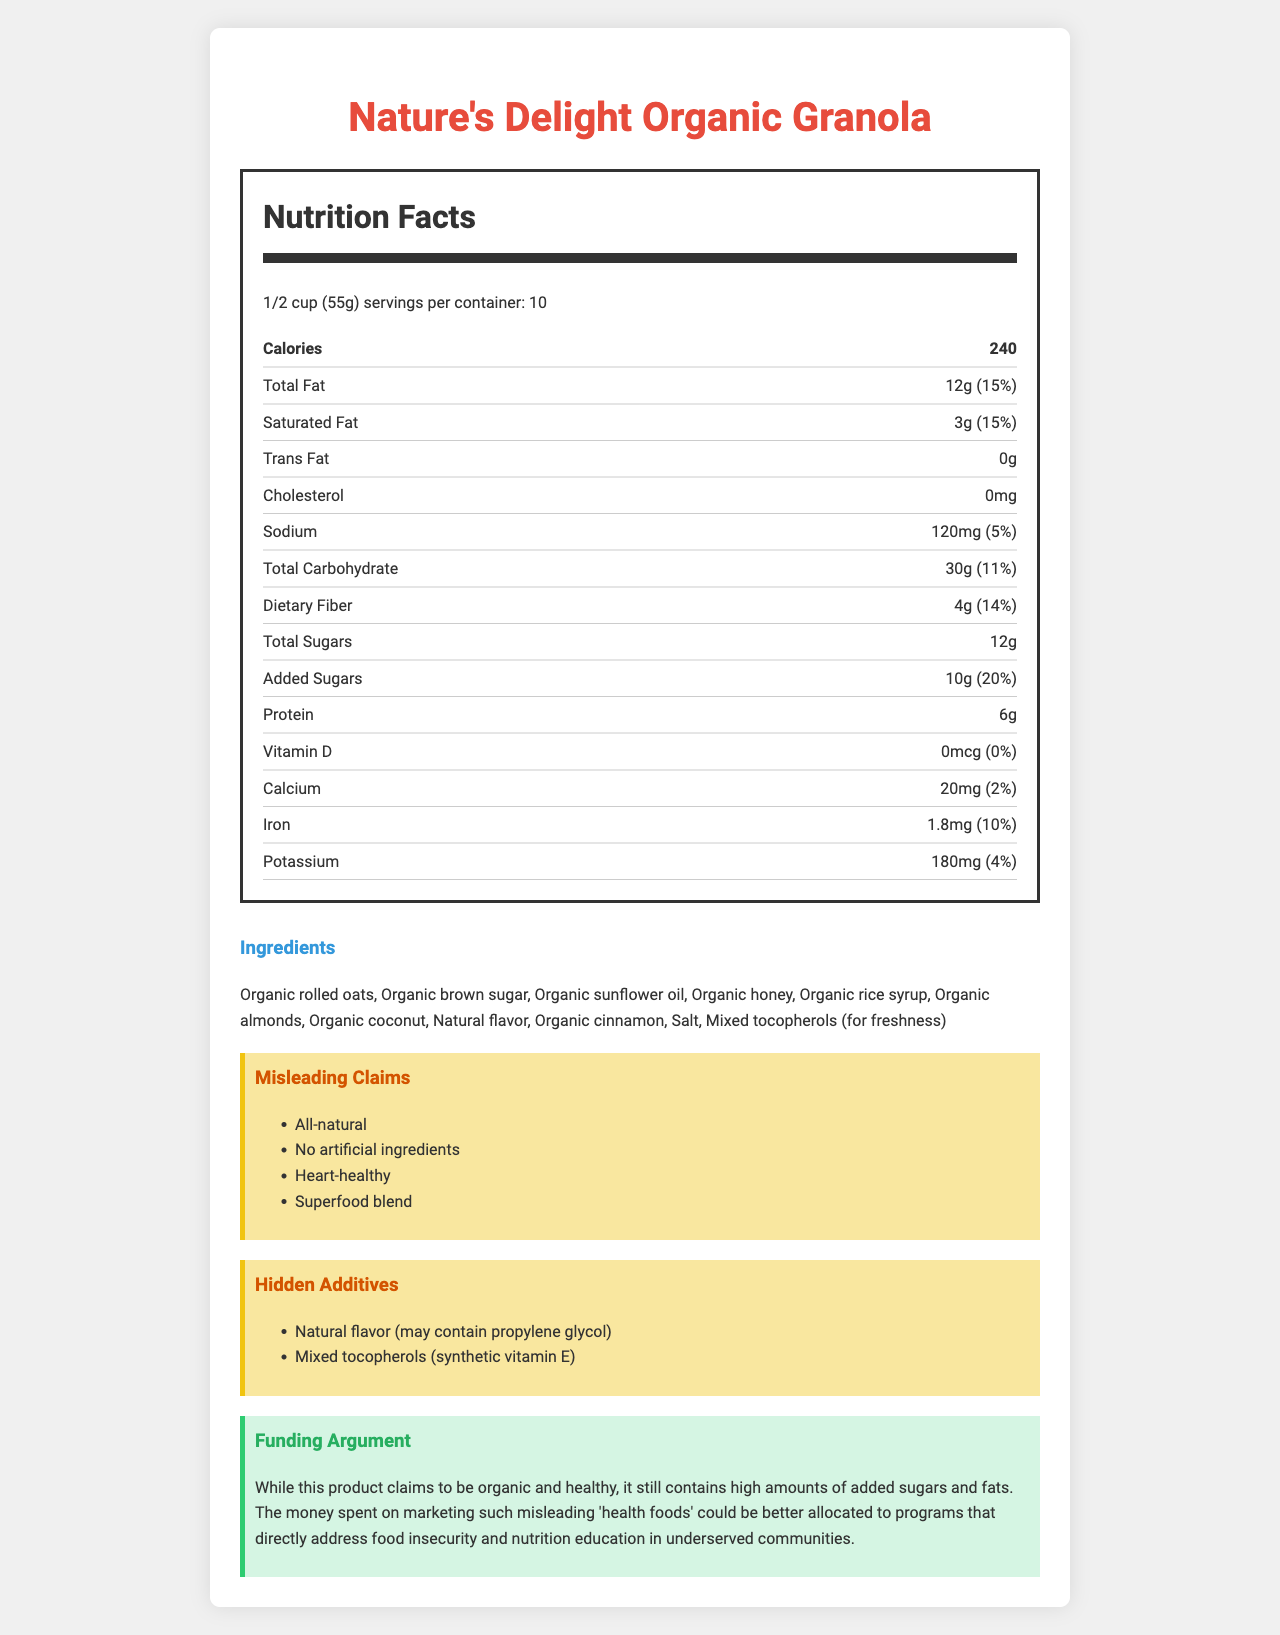What is the serving size for Nature's Delight Organic Granola? The serving size is clearly stated at the top of the Nutrition Facts label.
Answer: 1/2 cup (55g) How many calories are in one serving? The Nutrition Facts label lists the number of calories per serving as 240.
Answer: 240 How much is the total fat content per serving? The Nutrition Facts label specifies that the total fat content per serving is 12g.
Answer: 12g What is the amount of dietary fiber per serving? The amount of dietary fiber per serving is listed as 4g in the Nutrition Facts.
Answer: 4g What percentage of the daily value does the added sugars constitute? The label shows that added sugars are 10g per serving, which is 20% of the daily value.
Answer: 20% Which of the following is a hidden additive in the granola? A. Organic honey B. Natural flavor C. Organic rolled oats D. Organic brown sugar Natural flavor is identified as one of the hidden additives that may contain propylene glycol.
Answer: B Identify one misleading health claim made by the product. The document indicates that "Heart-healthy" is one of the misleading claims made by the product.
Answer: Heart-healthy How many servings are there per container? The Nutrition Facts label indicates that there are 10 servings per container.
Answer: 10 Is the granola cholesterol-free? The Nutrition Facts label lists cholesterol as 0mg, indicating that it is cholesterol-free.
Answer: Yes Why might someone argue that the funding for marketing this product should be reallocated? The argument section states that the product contains high amounts of added sugars and fats, suggesting funds could be better spent on addressing food insecurity and nutrition education.
Answer: High amounts of added sugars and fats Does the product contain any synthetic additives? The document lists mixed tocopherols (synthetic vitamin E) as a hidden additive.
Answer: Yes Estimate the total amount of carbohydrates in the entire container. With 30g of total carbohydrates per serving and 10 servings per container, the total amount is 30g x 10 = 300g.
Answer: 300g Summarize the main points of the document. The document provides a detailed breakdown of the nutritional content, ingredients, and misleading marketing claims of the granola, emphasizing the need for funding to be used on other social programs instead.
Answer: The document analyzes the Nutrition Facts label for Nature's Delight Organic Granola, pointing out high levels of added sugars and fats despite its health claims. It highlights misleading claims and hidden additives while arguing for reallocating marketing funds to more impactful social programs. What is the amount of Vitamin D per serving? The Nutrition Facts label indicates that Vitamin D is 0mcg per serving.
Answer: 0mcg How much iron is in the granola? The label lists that one serving contains 1.8mg of iron.
Answer: 1.8mg What are the first three ingredients listed? The ingredients section lists these as the first three ingredients.
Answer: Organic rolled oats, Organic brown sugar, Organic sunflower oil What type of questions were asked to generate this document? The question about the type of questions used to generate the document cannot be determined from the visual document alone.
Answer: Not enough information 